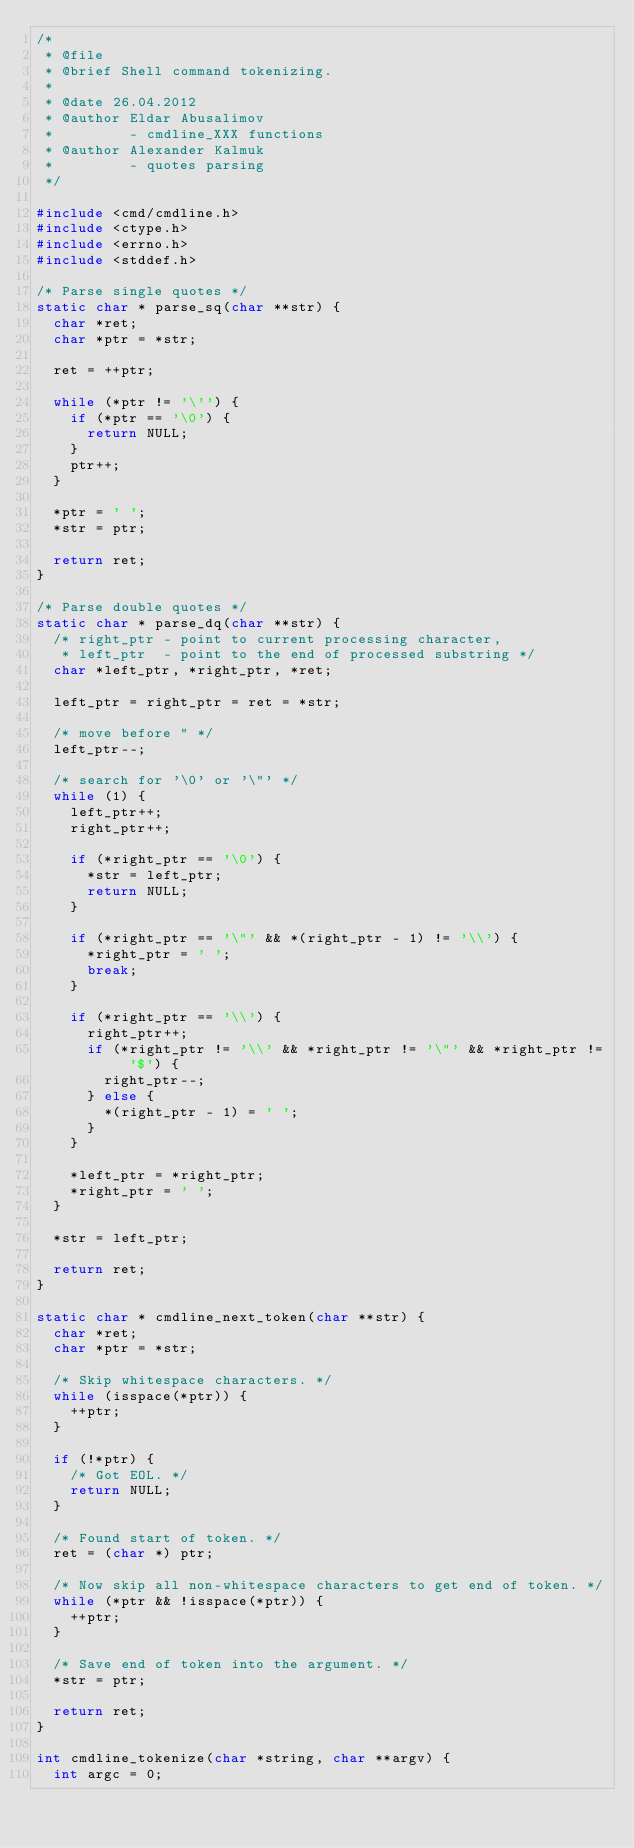<code> <loc_0><loc_0><loc_500><loc_500><_C_>/*
 * @file
 * @brief Shell command tokenizing.
 *
 * @date 26.04.2012
 * @author Eldar Abusalimov
 *         - cmdline_XXX functions
 * @author Alexander Kalmuk
 *         - quotes parsing
 */

#include <cmd/cmdline.h>
#include <ctype.h>
#include <errno.h>
#include <stddef.h>

/* Parse single quotes */
static char * parse_sq(char **str) {
	char *ret;
	char *ptr = *str;

	ret = ++ptr;

	while (*ptr != '\'') {
		if (*ptr == '\0') {
			return NULL;
		}
		ptr++;
	}

	*ptr = ' ';
	*str = ptr;

	return ret;
}

/* Parse double quotes */
static char * parse_dq(char **str) {
	/* right_ptr - point to current processing character,
	 * left_ptr  - point to the end of processed substring */
	char *left_ptr, *right_ptr, *ret;

	left_ptr = right_ptr = ret = *str;

	/* move before " */
	left_ptr--;

	/* search for '\0' or '\"' */
	while (1) {
		left_ptr++;
		right_ptr++;

		if (*right_ptr == '\0') {
			*str = left_ptr;
			return NULL;
		}

		if (*right_ptr == '\"' && *(right_ptr - 1) != '\\') {
			*right_ptr = ' ';
			break;
		}

		if (*right_ptr == '\\') {
			right_ptr++;
			if (*right_ptr != '\\' && *right_ptr != '\"' && *right_ptr != '$') {
				right_ptr--;
			} else {
				*(right_ptr - 1) = ' ';
			}
		}

		*left_ptr = *right_ptr;
		*right_ptr = ' ';
	}

	*str = left_ptr;

	return ret;
}

static char * cmdline_next_token(char **str) {
	char *ret;
	char *ptr = *str;

	/* Skip whitespace characters. */
	while (isspace(*ptr)) {
		++ptr;
	}

	if (!*ptr) {
		/* Got EOL. */
		return NULL;
	}

	/* Found start of token. */
	ret = (char *) ptr;

	/* Now skip all non-whitespace characters to get end of token. */
	while (*ptr && !isspace(*ptr)) {
		++ptr;
	}

	/* Save end of token into the argument. */
	*str = ptr;

	return ret;
}

int cmdline_tokenize(char *string, char **argv) {
	int argc = 0;
</code> 